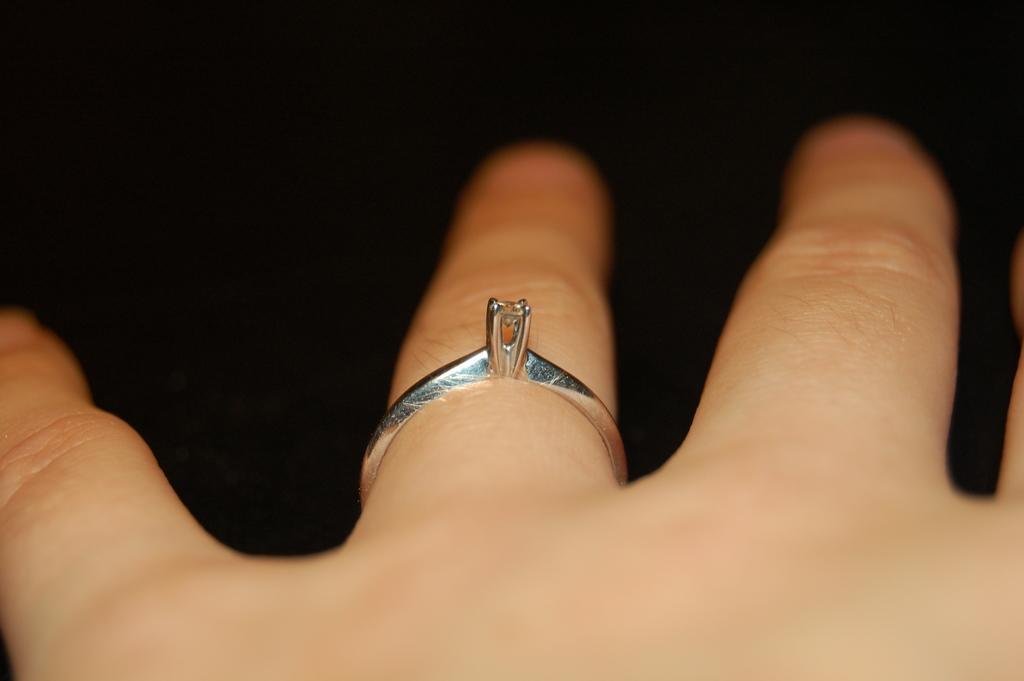Describe this image in one or two sentences. In this image we can see a ring to the finger of a person. 